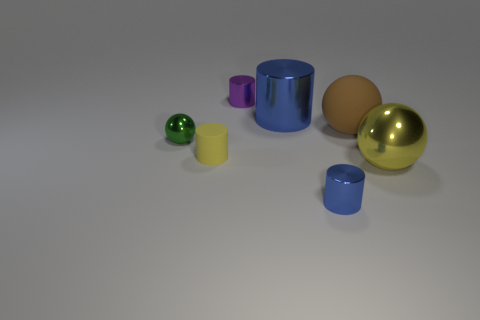What size is the blue metal object in front of the brown matte object behind the small metal cylinder in front of the yellow sphere?
Keep it short and to the point. Small. What color is the matte object that is the same shape as the large blue metal thing?
Provide a short and direct response. Yellow. Is the number of tiny blue things that are behind the tiny blue shiny cylinder greater than the number of tiny blue metal objects?
Offer a very short reply. No. There is a tiny rubber thing; does it have the same shape as the rubber thing right of the tiny blue shiny cylinder?
Provide a short and direct response. No. Are there any other things that have the same size as the purple thing?
Make the answer very short. Yes. What size is the purple shiny object that is the same shape as the tiny yellow rubber object?
Your answer should be compact. Small. Is the number of tiny gray balls greater than the number of rubber balls?
Your response must be concise. No. Do the small matte thing and the small green metallic object have the same shape?
Ensure brevity in your answer.  No. What material is the yellow thing that is on the right side of the blue shiny cylinder in front of the yellow cylinder?
Give a very brief answer. Metal. There is a big sphere that is the same color as the tiny rubber thing; what is it made of?
Ensure brevity in your answer.  Metal. 